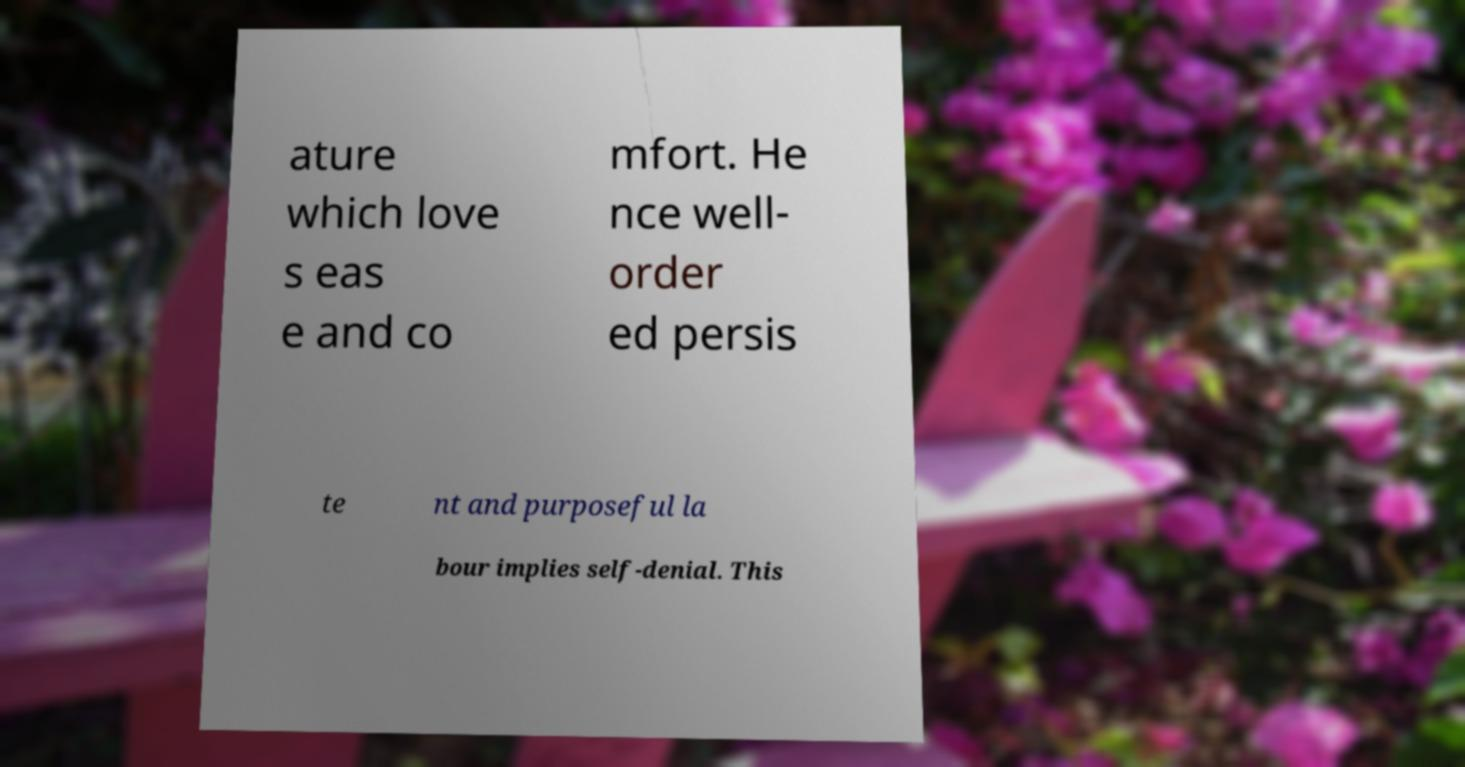For documentation purposes, I need the text within this image transcribed. Could you provide that? ature which love s eas e and co mfort. He nce well- order ed persis te nt and purposeful la bour implies self-denial. This 